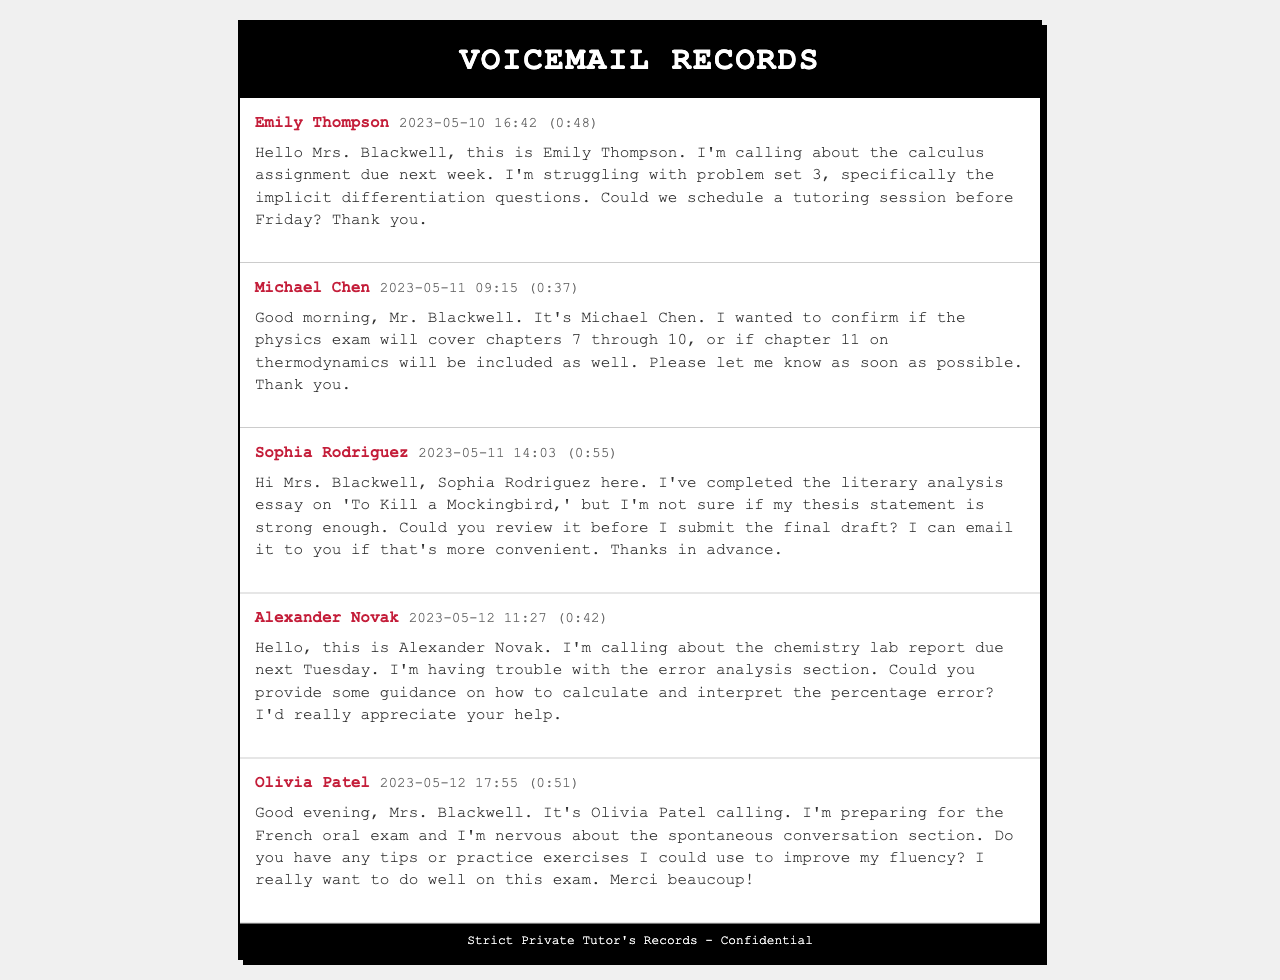What is the name of the first student who left a voicemail? The first student who left a voicemail is Emily Thompson.
Answer: Emily Thompson What is the date and time of Michael Chen's voicemail? Michael Chen's voicemail was left on May 11, 2023, at 09:15.
Answer: 2023-05-11 09:15 How long was Sophia Rodriguez's voicemail? The duration of Sophia Rodriguez's voicemail is 0:55.
Answer: (0:55) What subject is Alexander Novak requesting help with? Alexander Novak is requesting help with the chemistry lab report.
Answer: Chemistry What specific topic did Olivia Patel mention needing tips for? Olivia Patel mentioned needing tips for the spontaneous conversation section of the French oral exam.
Answer: Spontaneous conversation How many voicemails were left by students in total? There are five voicemails left by students in total.
Answer: 5 What is the main concern expressed by Emily Thompson? Emily Thompson's main concern is with problem set 3 of the calculus assignment.
Answer: Implicit differentiation questions Which student needs their thesis statement reviewed? Sophia Rodriguez needs her thesis statement reviewed.
Answer: Sophia Rodriguez What deadline does Alexander Novak mention for the chemistry lab report? Alexander Novak mentions that the chemistry lab report is due next Tuesday.
Answer: Next Tuesday 